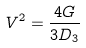<formula> <loc_0><loc_0><loc_500><loc_500>V ^ { 2 } = \frac { 4 G } { 3 D _ { 3 } }</formula> 